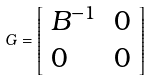<formula> <loc_0><loc_0><loc_500><loc_500>G = { \left [ \begin{array} { l l } { B ^ { - 1 } } & { 0 } \\ { 0 } & { 0 } \end{array} \right ] }</formula> 